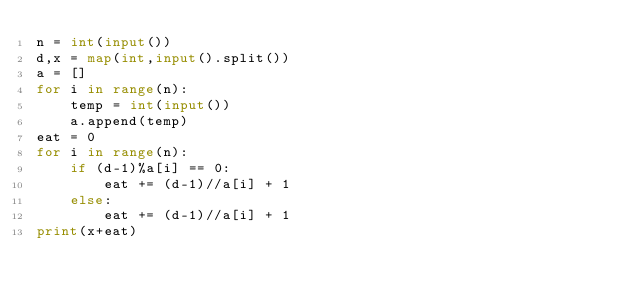Convert code to text. <code><loc_0><loc_0><loc_500><loc_500><_Python_>n = int(input())
d,x = map(int,input().split())
a = []
for i in range(n):
	temp = int(input())
	a.append(temp)
eat = 0
for i in range(n):
	if (d-1)%a[i] == 0:
		eat += (d-1)//a[i] + 1
	else:
		eat += (d-1)//a[i] + 1
print(x+eat)</code> 